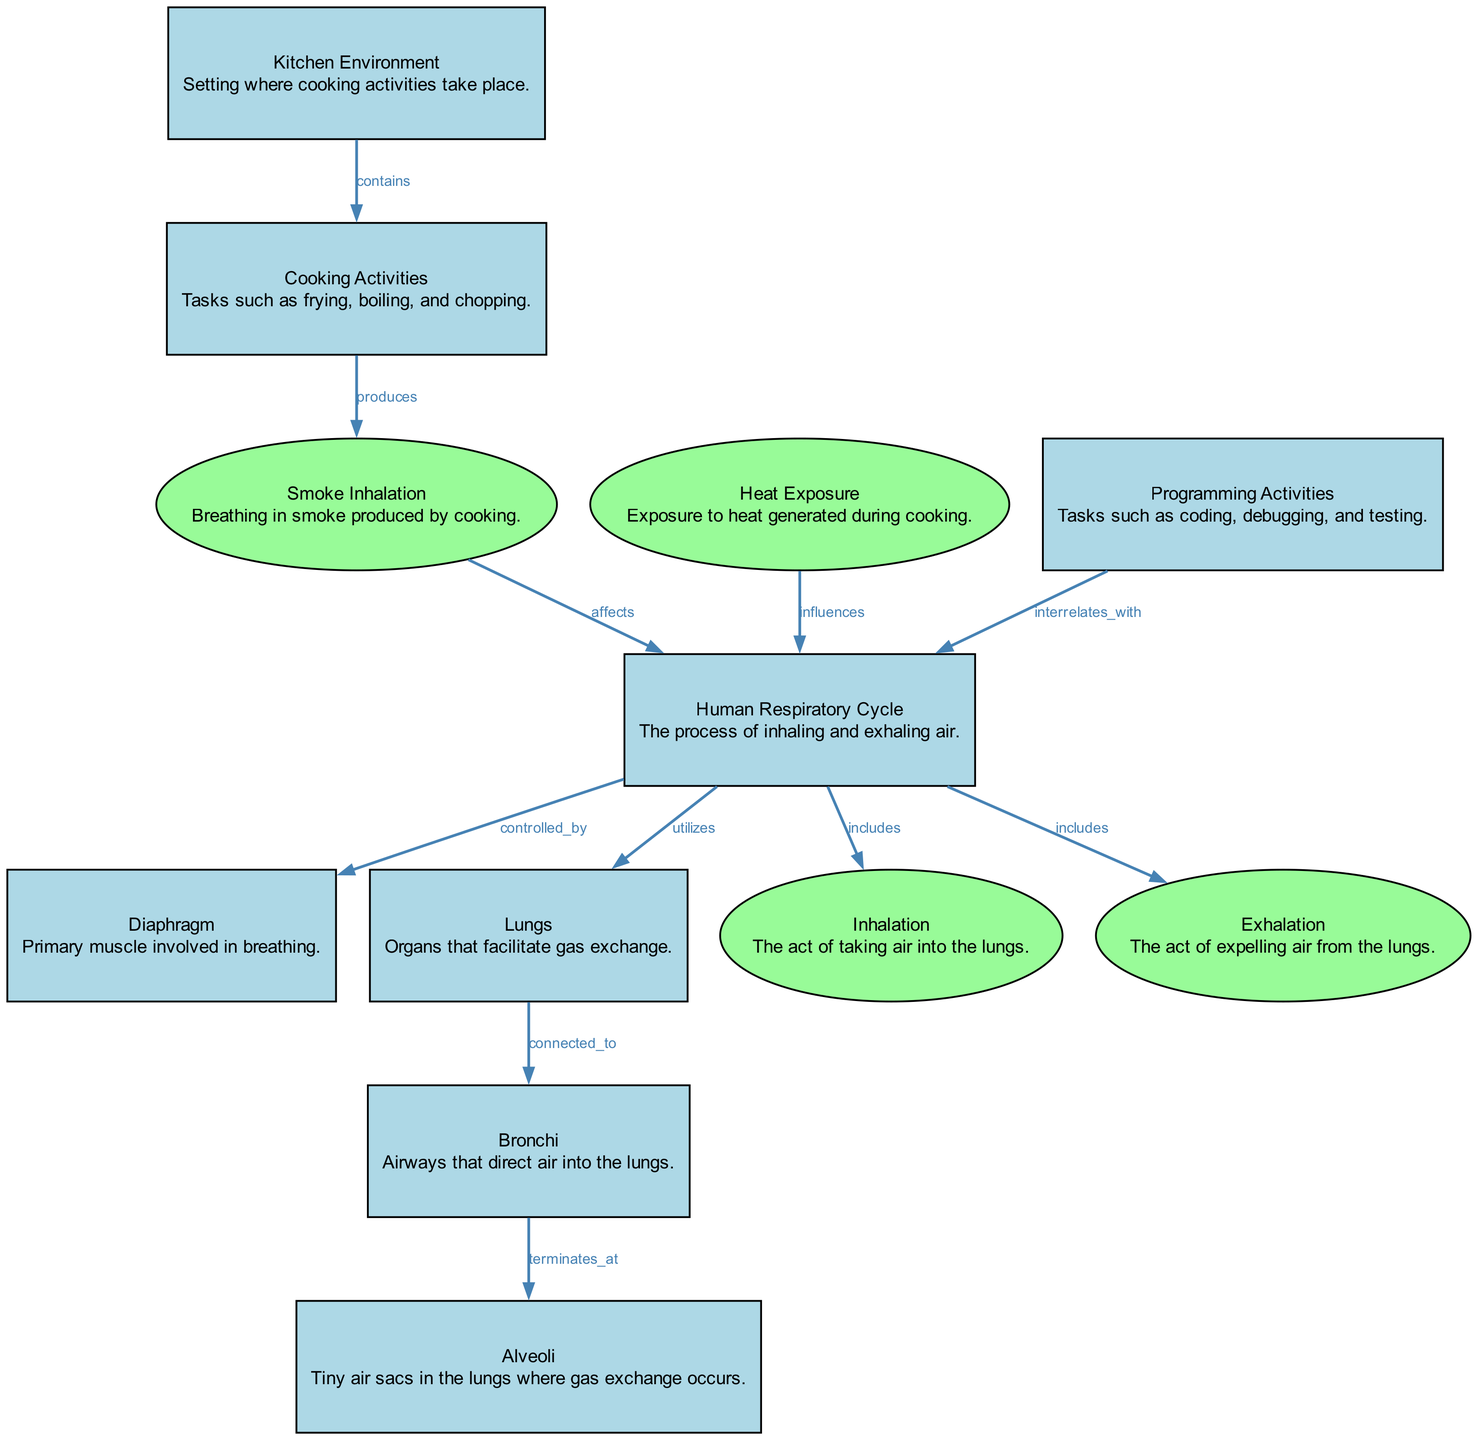What is the primary muscle involved in the Human Respiratory Cycle? The diagram identifies the diaphragm as the primary muscle associated with the Human Respiratory Cycle, as indicated by the edge connecting these two nodes labeled "controlled_by."
Answer: Diaphragm How many processes are shown in the diagram? To find the number of processes, we can count the nodes labeled as processes in the diagram. There are five processes: Inhalation, Exhalation, Smoke Inhalation, Heat Exposure, and Programming Activities.
Answer: Five What does smoke inhalation affect? The edge labeled "affects" connects smoke inhalation to the human respiratory cycle, indicating its direct impact.
Answer: Human Respiratory Cycle What influence does heat exposure have on respiration? The edge labeled "influences" describes that heat exposure specifically influences the respiration rate, connecting the heat exposure node to the human respiratory cycle.
Answer: Respiration rate Which nodes are connected to the lungs? The lungs node is connected to two other nodes: bronchi (as indicated by "connected_to") and the human respiratory cycle (as it utilizes the lungs for gas exchange).
Answer: Bronchi and Human Respiratory Cycle What type of environment is mentioned in the diagram? The diagram mentions "Kitchen Environment," which is explicitly defined as the setting where cooking activities occur.
Answer: Kitchen Environment What processes are included in the human respiratory cycle? The edge labeled "includes" connects the human respiratory cycle to the processes of inhalation and exhalation, indicating these are part of the cycle.
Answer: Inhalation and Exhalation What is produced by cooking activities? The edge labeled "produces" shows that cooking activities specifically produce smoke, demonstrating their impact on the environment.
Answer: Smoke Which activities may affect breathing due to concentration? The diagram states that programming activities interrelate with the human respiratory cycle, suggesting that the concentration required for programming may affect breathing.
Answer: Programming Activities 